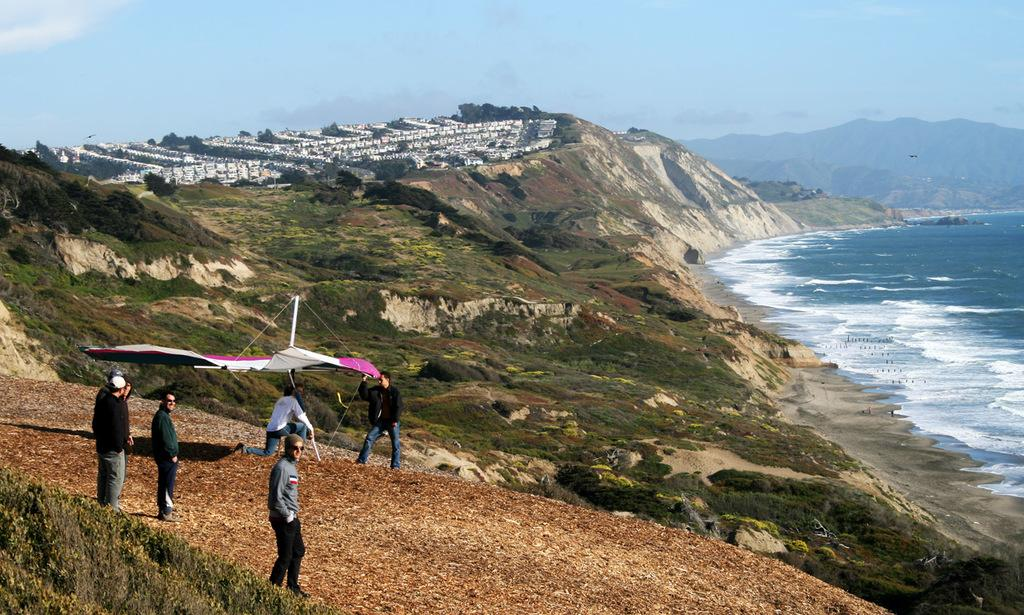What are the people in the image doing? The people in the image are standing on rocks. What can be seen in the background of the image? There are trees visible in the image. What is happening with the water in the image? There is water flow visible in the image. What type of hydrant can be seen in the image? There is no hydrant present in the image. What is the title of the image? The provided facts do not mention a title for the image. 